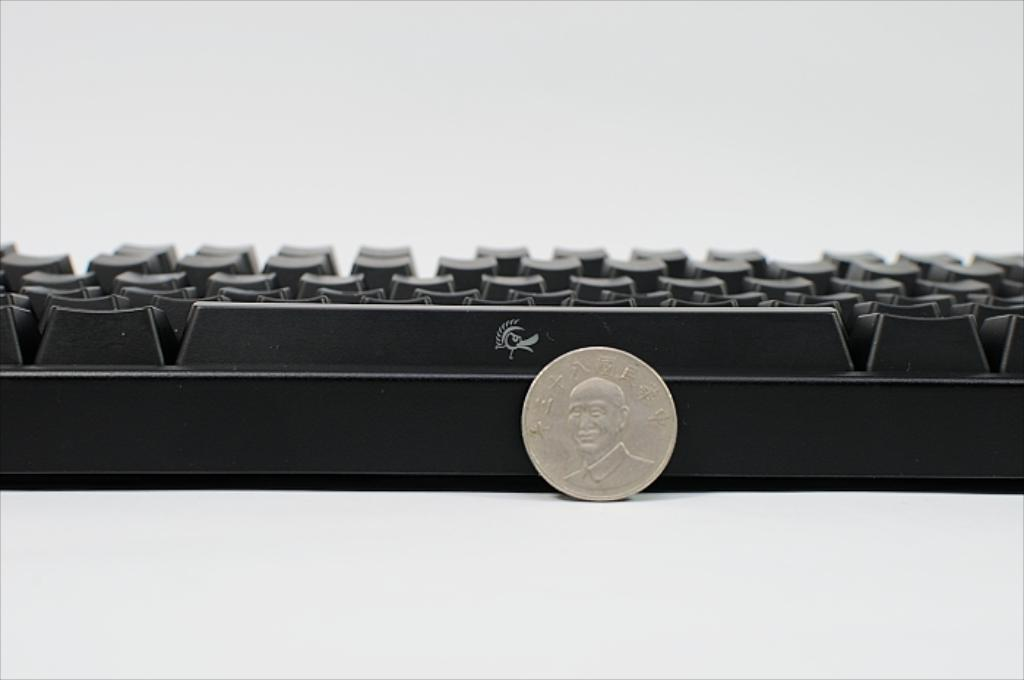What object can be seen in the image that is typically used for making transactions? There is a coin in the image, which is commonly used for making transactions. What other object is visible in the image that is used for inputting data? There is a keyboard in the image, which is used for inputting data. What color is the background of the image? The background of the image is white. How many dogs are visible in the image? There are no dogs present in the image. Can you compare the size of the coin to the keyboard in the image? It is not possible to compare the size of the coin to the keyboard in the image, as the image does not provide a reference for scale. 